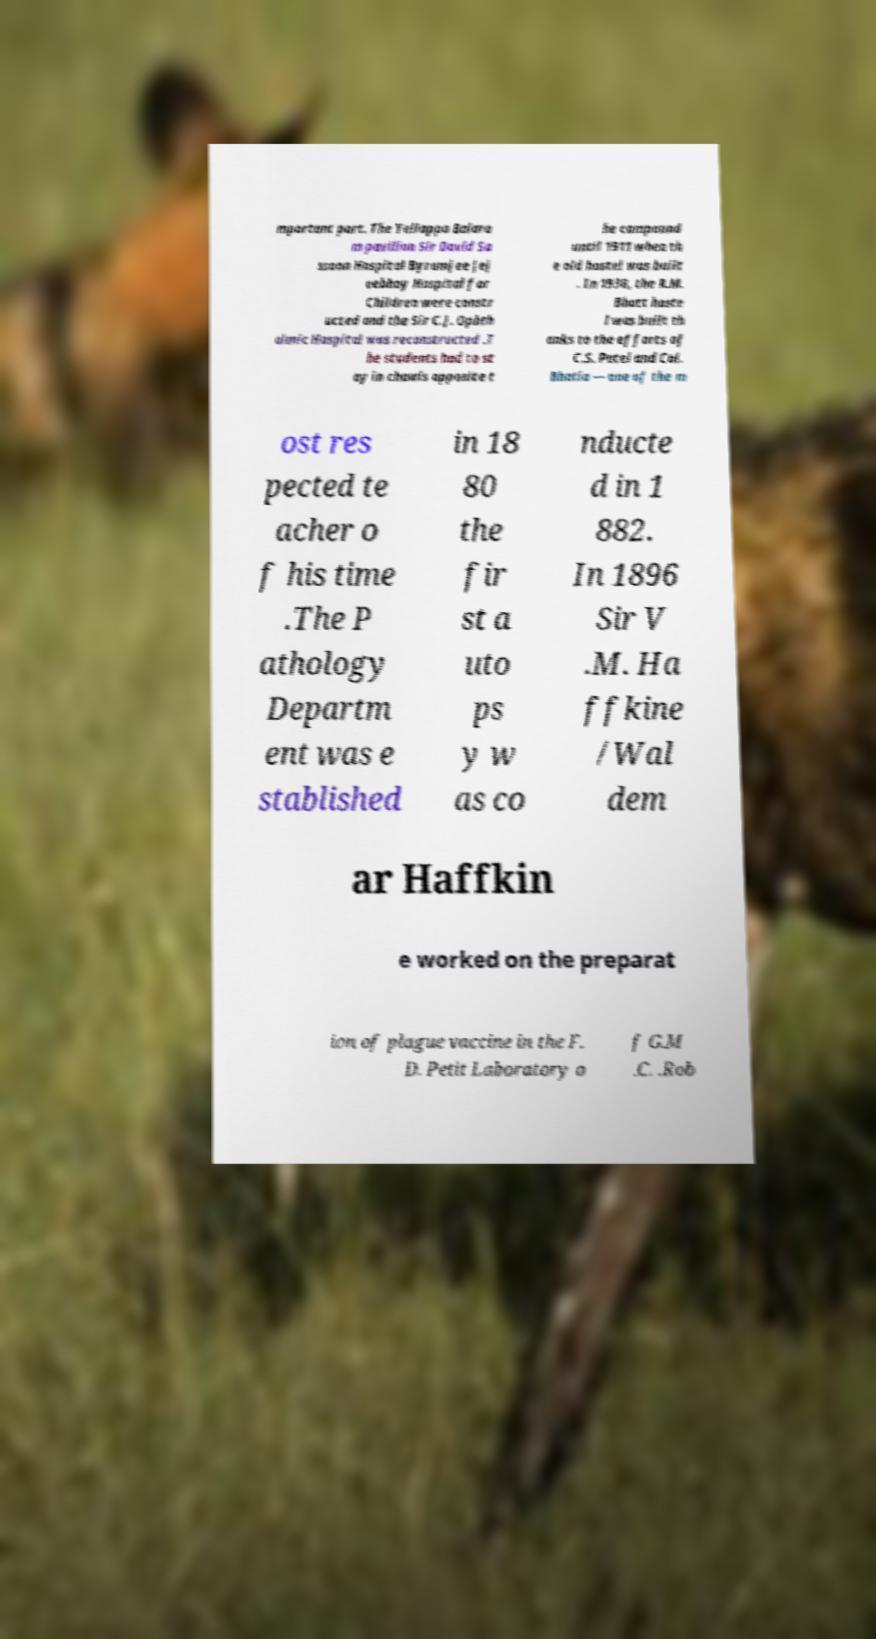For documentation purposes, I need the text within this image transcribed. Could you provide that? mportant part. The Yellappa Balara m pavilion Sir David Sa ssoon Hospital Byramjee Jej eebhoy Hospital for Children were constr ucted and the Sir C.J. Ophth almic Hospital was reconstructed .T he students had to st ay in chawls opposite t he compound until 1911 when th e old hostel was built . In 1938, the R.M. Bhatt hoste l was built th anks to the efforts of C.S. Patel and Col. Bhatia — one of the m ost res pected te acher o f his time .The P athology Departm ent was e stablished in 18 80 the fir st a uto ps y w as co nducte d in 1 882. In 1896 Sir V .M. Ha ffkine /Wal dem ar Haffkin e worked on the preparat ion of plague vaccine in the F. D. Petit Laboratory o f G.M .C. .Rob 